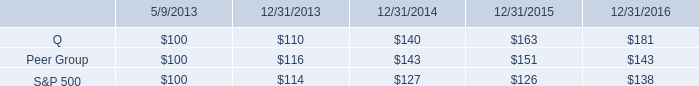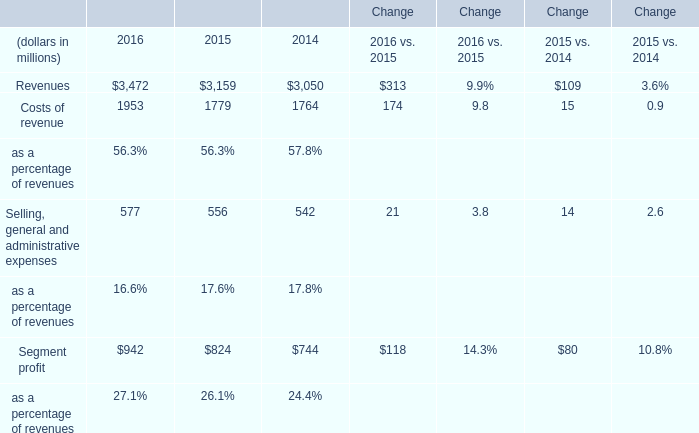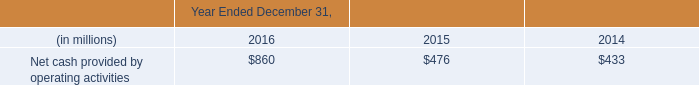what is the return on investment for s&p500 if the investment is sold at the end of year 2014? 
Computations: ((127 - 100) / 100)
Answer: 0.27. 